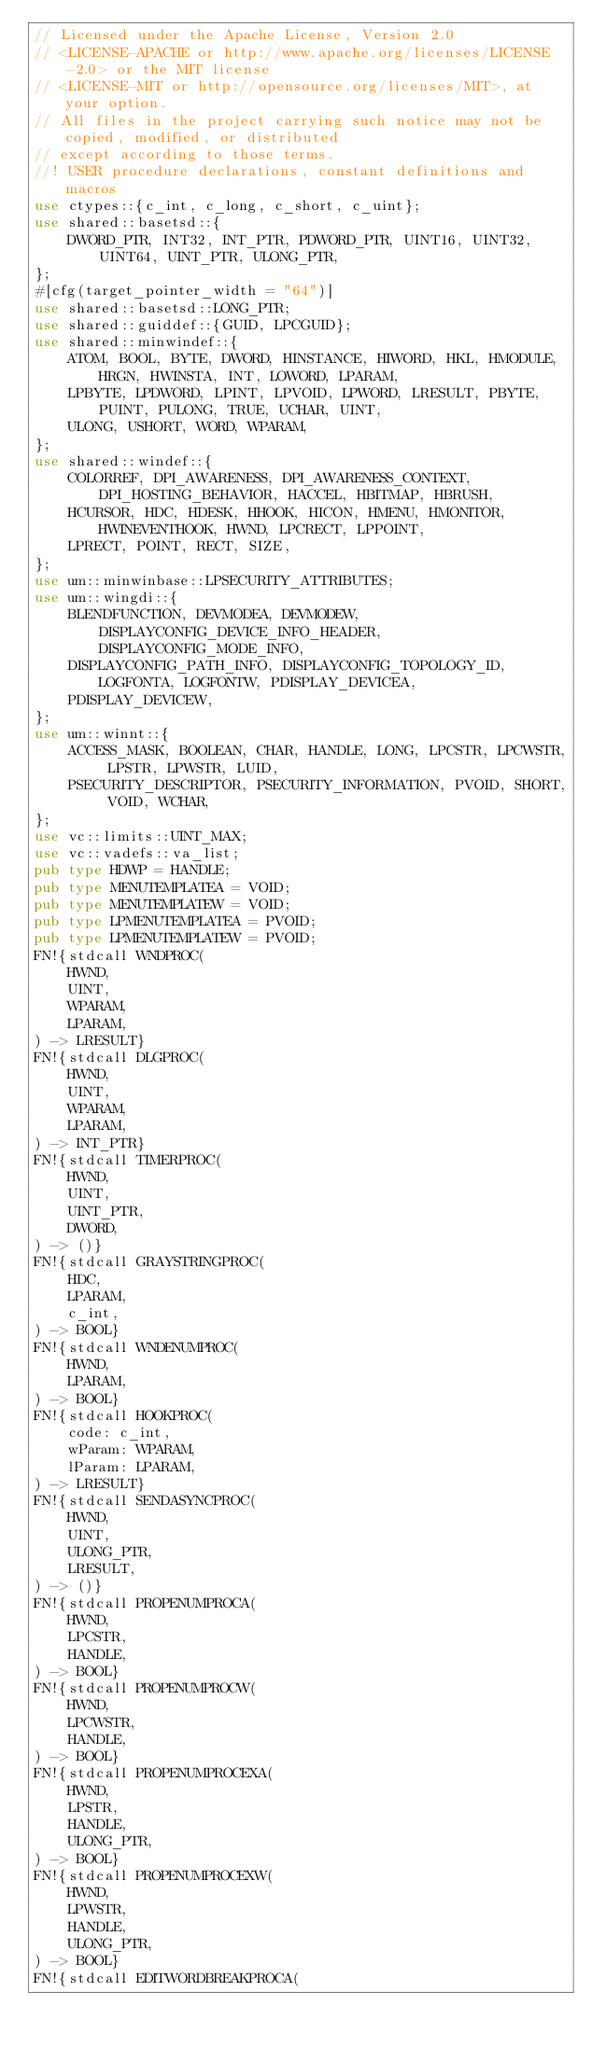<code> <loc_0><loc_0><loc_500><loc_500><_Rust_>// Licensed under the Apache License, Version 2.0
// <LICENSE-APACHE or http://www.apache.org/licenses/LICENSE-2.0> or the MIT license
// <LICENSE-MIT or http://opensource.org/licenses/MIT>, at your option.
// All files in the project carrying such notice may not be copied, modified, or distributed
// except according to those terms.
//! USER procedure declarations, constant definitions and macros
use ctypes::{c_int, c_long, c_short, c_uint};
use shared::basetsd::{
    DWORD_PTR, INT32, INT_PTR, PDWORD_PTR, UINT16, UINT32, UINT64, UINT_PTR, ULONG_PTR,
};
#[cfg(target_pointer_width = "64")]
use shared::basetsd::LONG_PTR;
use shared::guiddef::{GUID, LPCGUID};
use shared::minwindef::{
    ATOM, BOOL, BYTE, DWORD, HINSTANCE, HIWORD, HKL, HMODULE, HRGN, HWINSTA, INT, LOWORD, LPARAM,
    LPBYTE, LPDWORD, LPINT, LPVOID, LPWORD, LRESULT, PBYTE, PUINT, PULONG, TRUE, UCHAR, UINT,
    ULONG, USHORT, WORD, WPARAM,
};
use shared::windef::{
    COLORREF, DPI_AWARENESS, DPI_AWARENESS_CONTEXT, DPI_HOSTING_BEHAVIOR, HACCEL, HBITMAP, HBRUSH,
    HCURSOR, HDC, HDESK, HHOOK, HICON, HMENU, HMONITOR, HWINEVENTHOOK, HWND, LPCRECT, LPPOINT,
    LPRECT, POINT, RECT, SIZE,
};
use um::minwinbase::LPSECURITY_ATTRIBUTES;
use um::wingdi::{
    BLENDFUNCTION, DEVMODEA, DEVMODEW, DISPLAYCONFIG_DEVICE_INFO_HEADER, DISPLAYCONFIG_MODE_INFO,
    DISPLAYCONFIG_PATH_INFO, DISPLAYCONFIG_TOPOLOGY_ID, LOGFONTA, LOGFONTW, PDISPLAY_DEVICEA,
    PDISPLAY_DEVICEW,
};
use um::winnt::{
    ACCESS_MASK, BOOLEAN, CHAR, HANDLE, LONG, LPCSTR, LPCWSTR, LPSTR, LPWSTR, LUID,
    PSECURITY_DESCRIPTOR, PSECURITY_INFORMATION, PVOID, SHORT, VOID, WCHAR,
};
use vc::limits::UINT_MAX;
use vc::vadefs::va_list;
pub type HDWP = HANDLE;
pub type MENUTEMPLATEA = VOID;
pub type MENUTEMPLATEW = VOID;
pub type LPMENUTEMPLATEA = PVOID;
pub type LPMENUTEMPLATEW = PVOID;
FN!{stdcall WNDPROC(
    HWND,
    UINT,
    WPARAM,
    LPARAM,
) -> LRESULT}
FN!{stdcall DLGPROC(
    HWND,
    UINT,
    WPARAM,
    LPARAM,
) -> INT_PTR}
FN!{stdcall TIMERPROC(
    HWND,
    UINT,
    UINT_PTR,
    DWORD,
) -> ()}
FN!{stdcall GRAYSTRINGPROC(
    HDC,
    LPARAM,
    c_int,
) -> BOOL}
FN!{stdcall WNDENUMPROC(
    HWND,
    LPARAM,
) -> BOOL}
FN!{stdcall HOOKPROC(
    code: c_int,
    wParam: WPARAM,
    lParam: LPARAM,
) -> LRESULT}
FN!{stdcall SENDASYNCPROC(
    HWND,
    UINT,
    ULONG_PTR,
    LRESULT,
) -> ()}
FN!{stdcall PROPENUMPROCA(
    HWND,
    LPCSTR,
    HANDLE,
) -> BOOL}
FN!{stdcall PROPENUMPROCW(
    HWND,
    LPCWSTR,
    HANDLE,
) -> BOOL}
FN!{stdcall PROPENUMPROCEXA(
    HWND,
    LPSTR,
    HANDLE,
    ULONG_PTR,
) -> BOOL}
FN!{stdcall PROPENUMPROCEXW(
    HWND,
    LPWSTR,
    HANDLE,
    ULONG_PTR,
) -> BOOL}
FN!{stdcall EDITWORDBREAKPROCA(</code> 